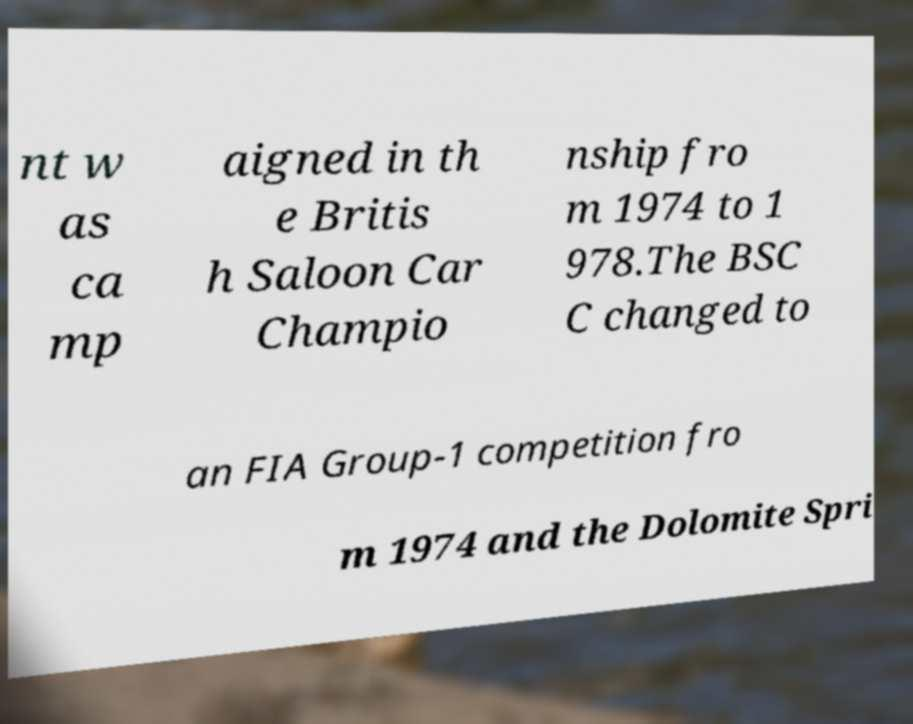There's text embedded in this image that I need extracted. Can you transcribe it verbatim? nt w as ca mp aigned in th e Britis h Saloon Car Champio nship fro m 1974 to 1 978.The BSC C changed to an FIA Group-1 competition fro m 1974 and the Dolomite Spri 